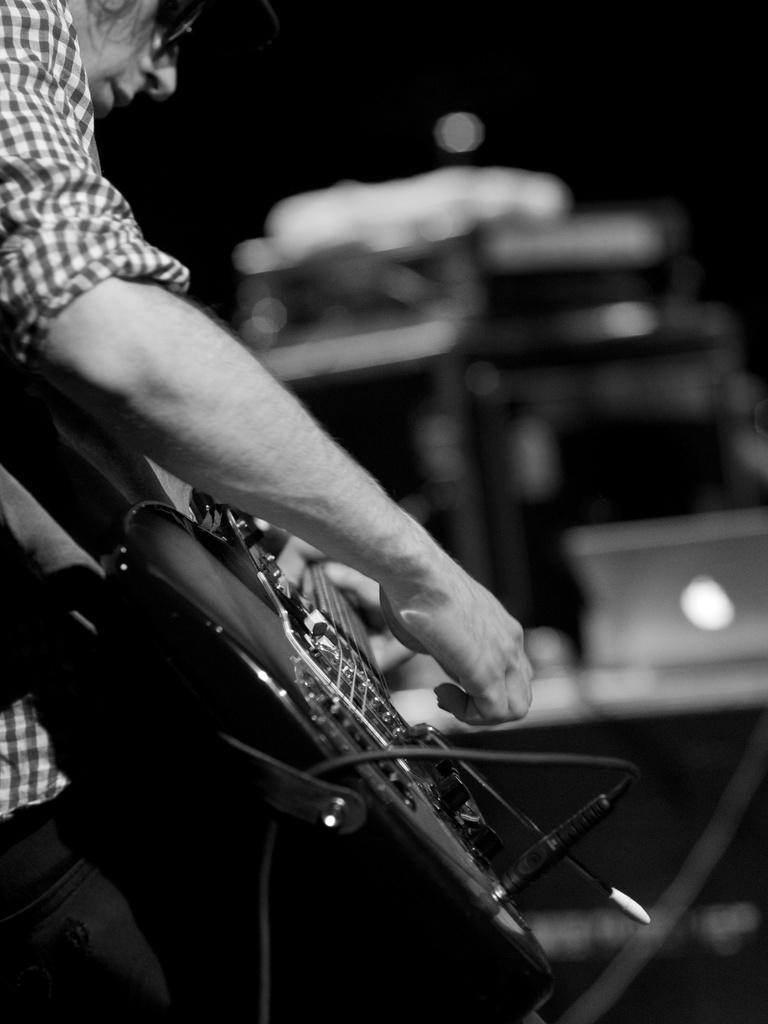In one or two sentences, can you explain what this image depicts? In this image there is a person holding a guitar. He is wearing spectacles. Background is blurry. 